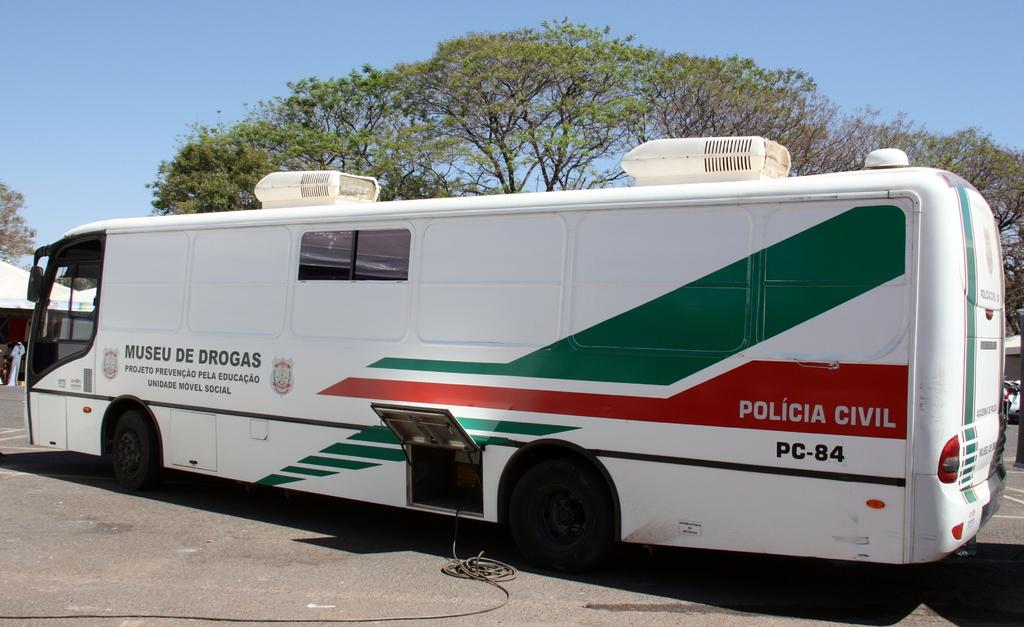What's the 4 digit number on the back?
Offer a terse response. Pc-84. What kind of vehicle is this?
Your answer should be compact. Policia civil. 